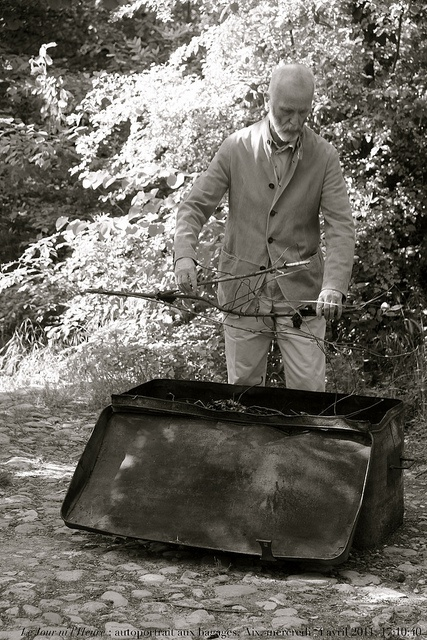Describe the objects in this image and their specific colors. I can see suitcase in black and gray tones and people in black, gray, and darkgray tones in this image. 